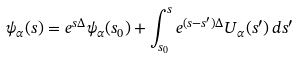<formula> <loc_0><loc_0><loc_500><loc_500>\psi _ { \alpha } ( s ) = e ^ { s \Delta } \psi _ { \alpha } ( s _ { 0 } ) + \int _ { s _ { 0 } } ^ { s } e ^ { ( s - s ^ { \prime } ) \Delta } U _ { \alpha } ( s ^ { \prime } ) \, d s ^ { \prime }</formula> 